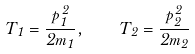Convert formula to latex. <formula><loc_0><loc_0><loc_500><loc_500>T _ { 1 } = \frac { \vec { p } _ { 1 } ^ { \, 2 } } { 2 m _ { 1 } } , \quad T _ { 2 } = \frac { \vec { p } _ { 2 } ^ { \, 2 } } { 2 m _ { 2 } }</formula> 